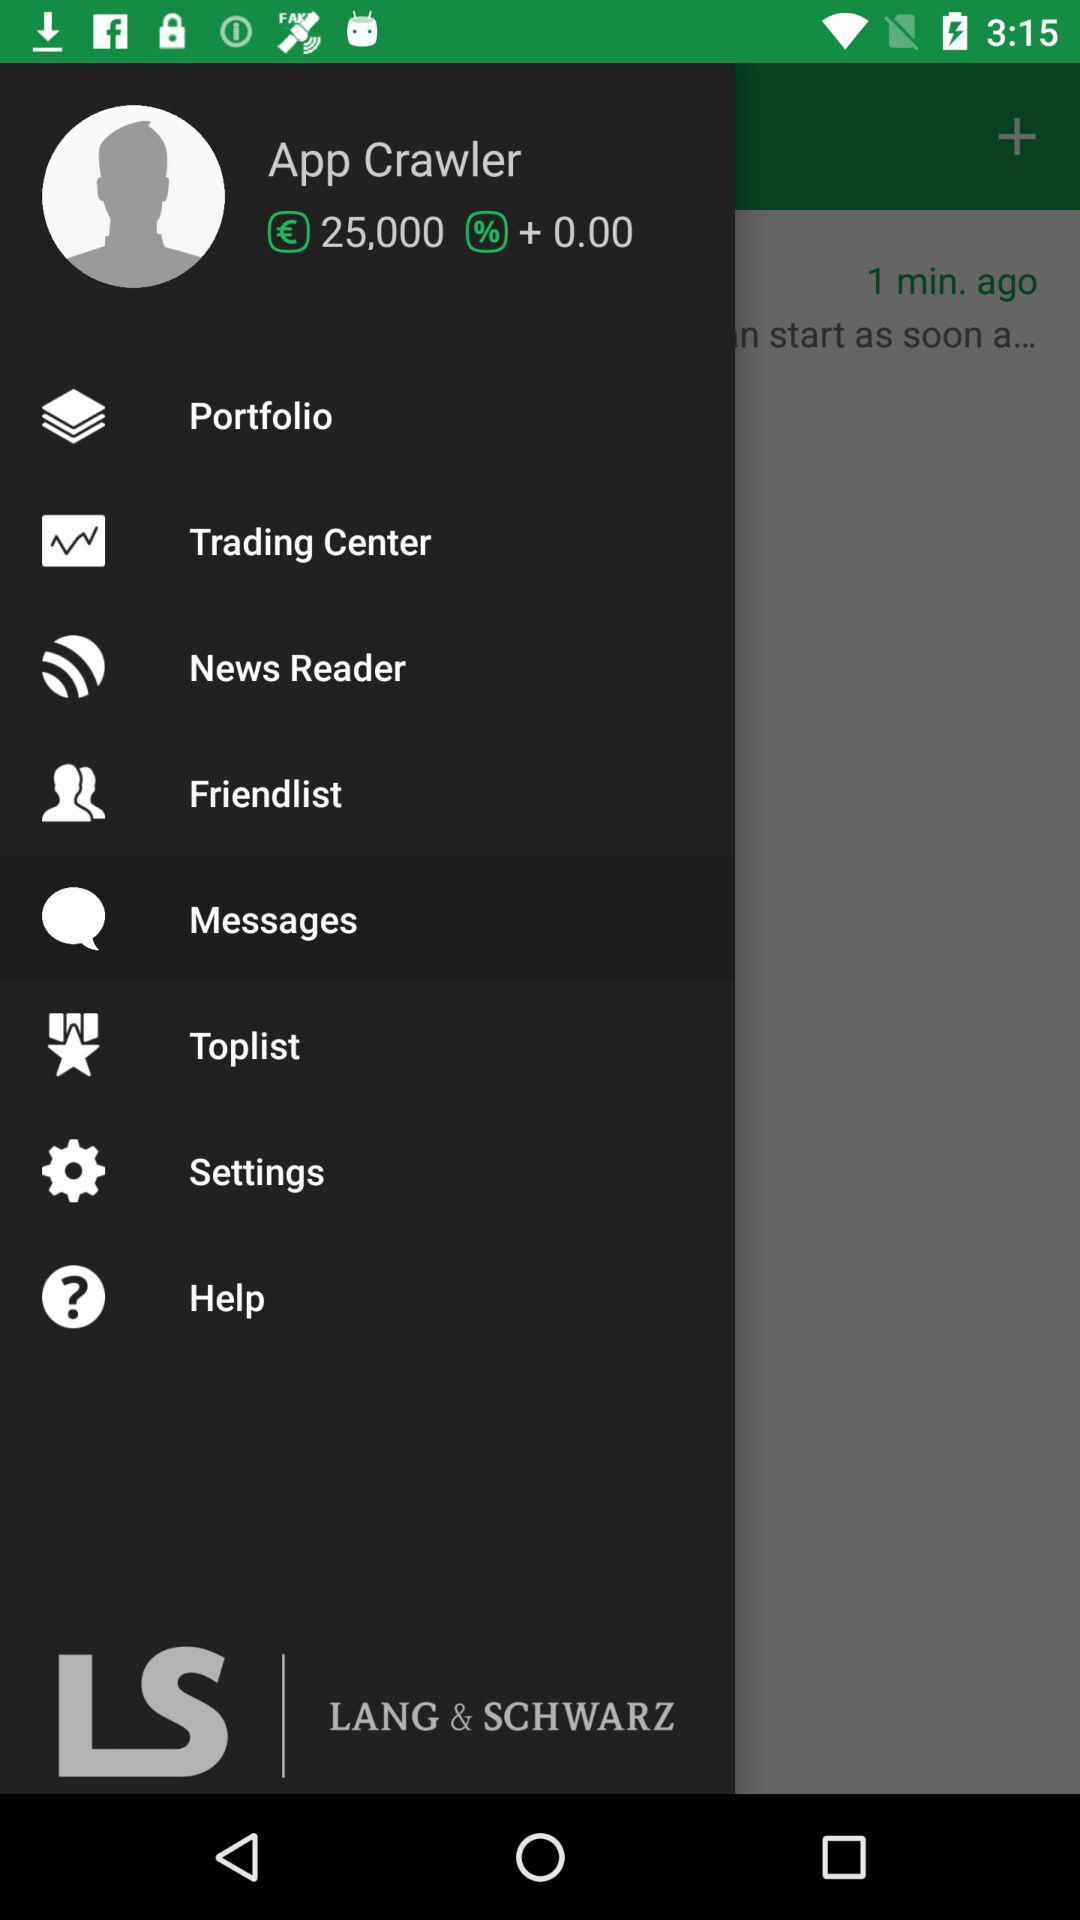What is the user name? The user name is App Crawler. 